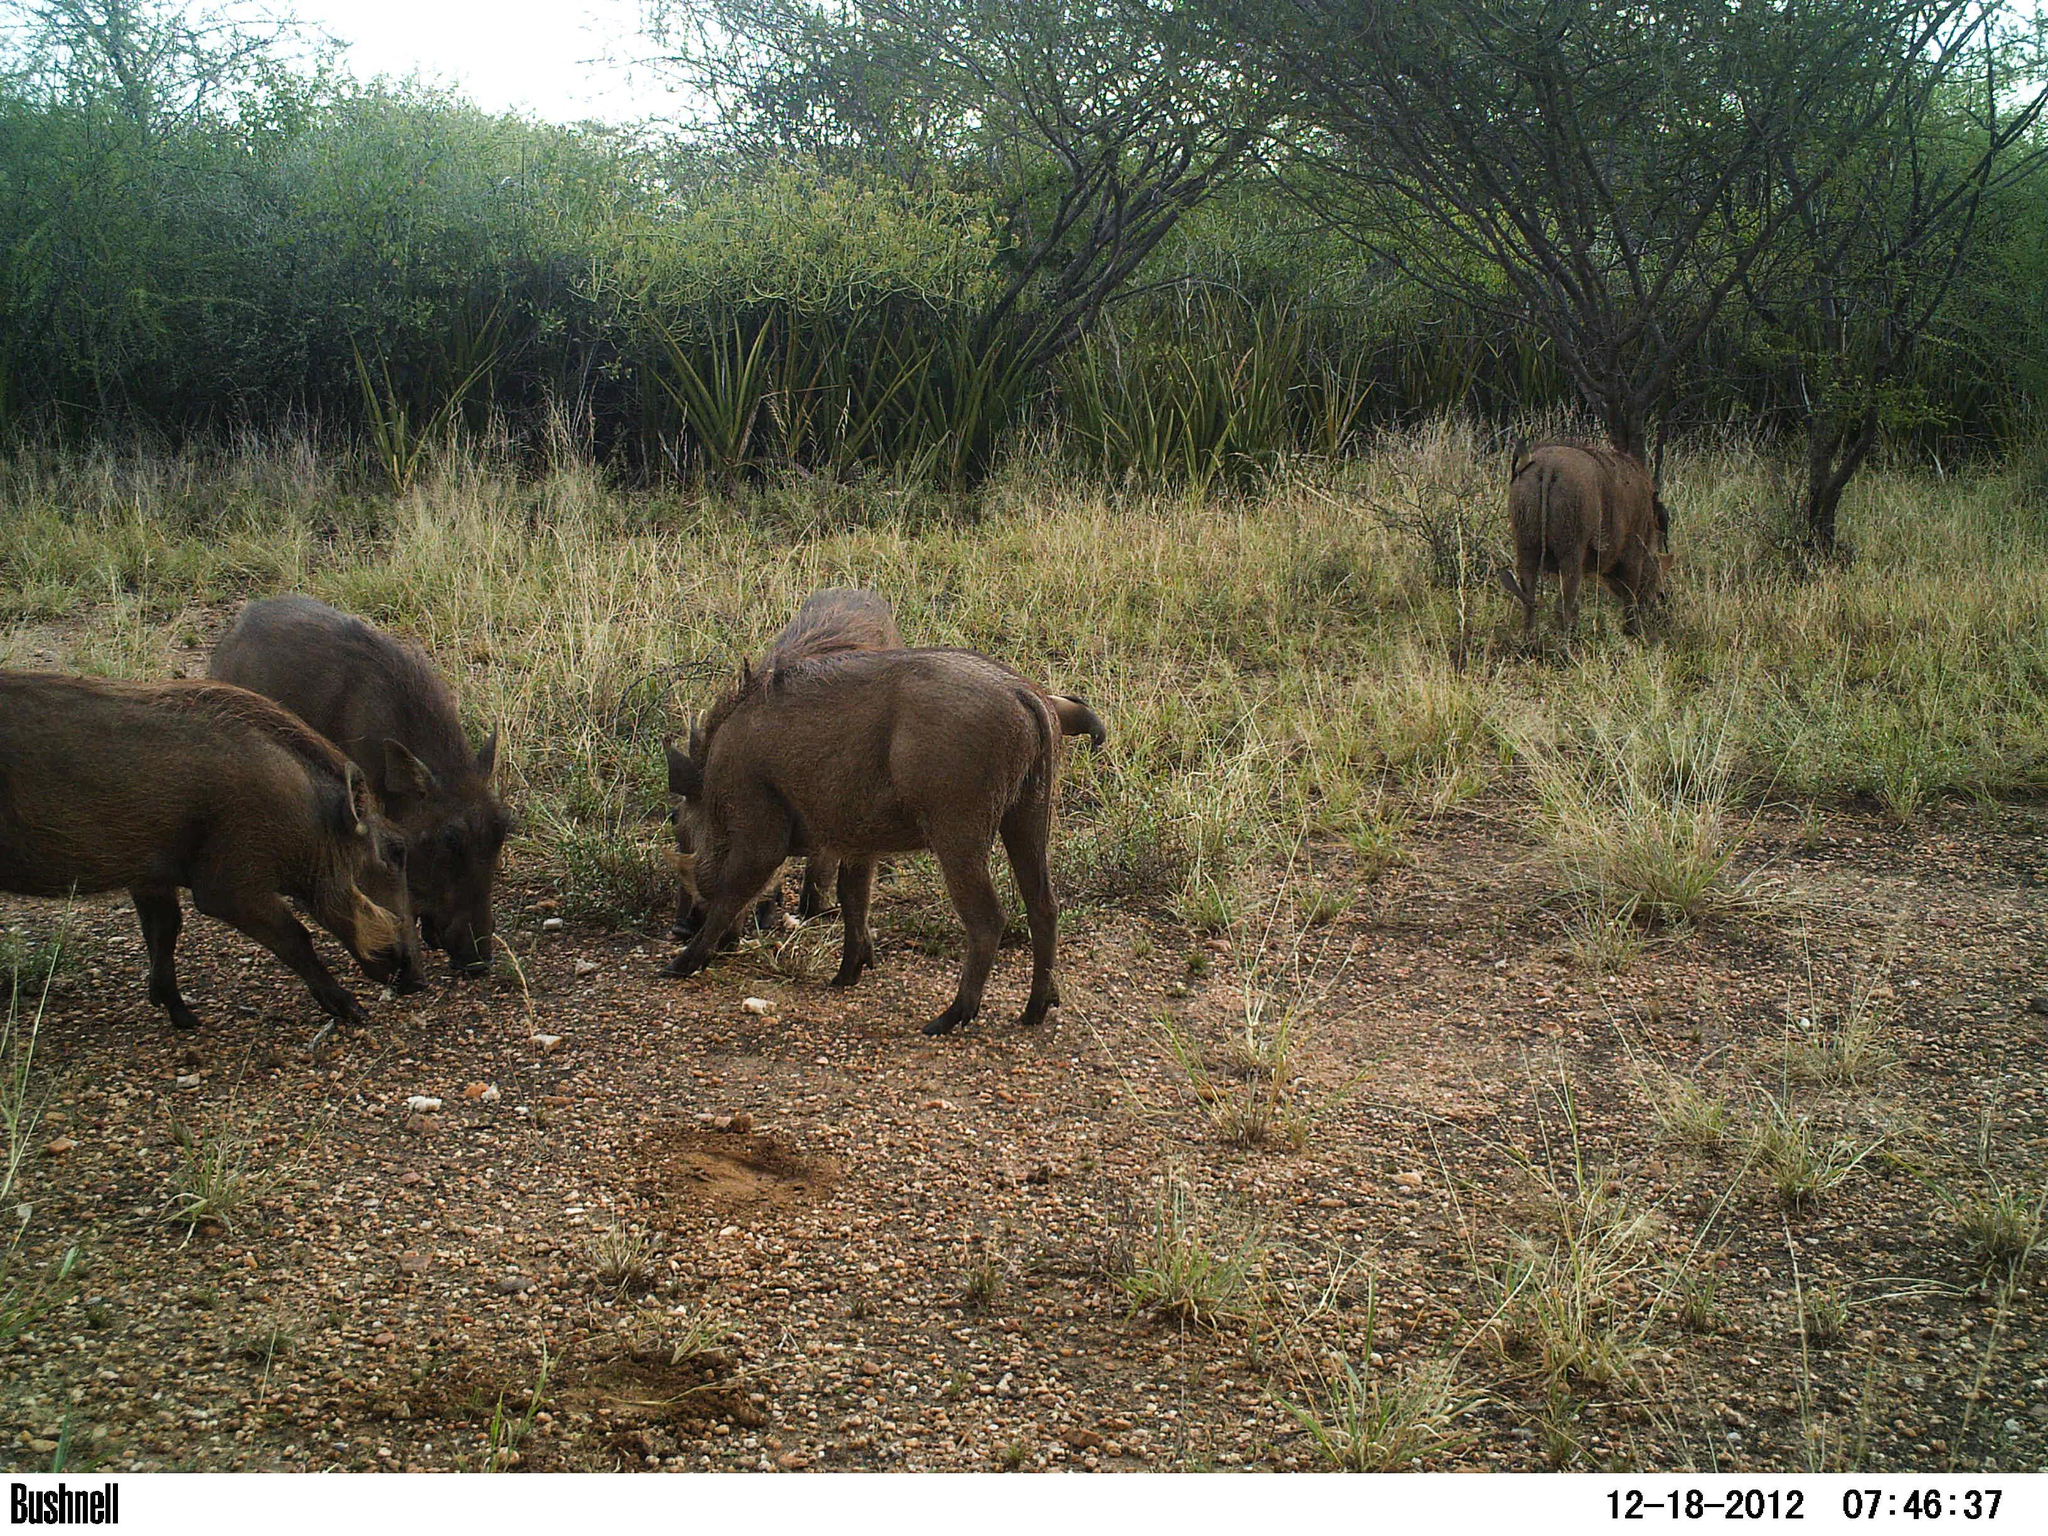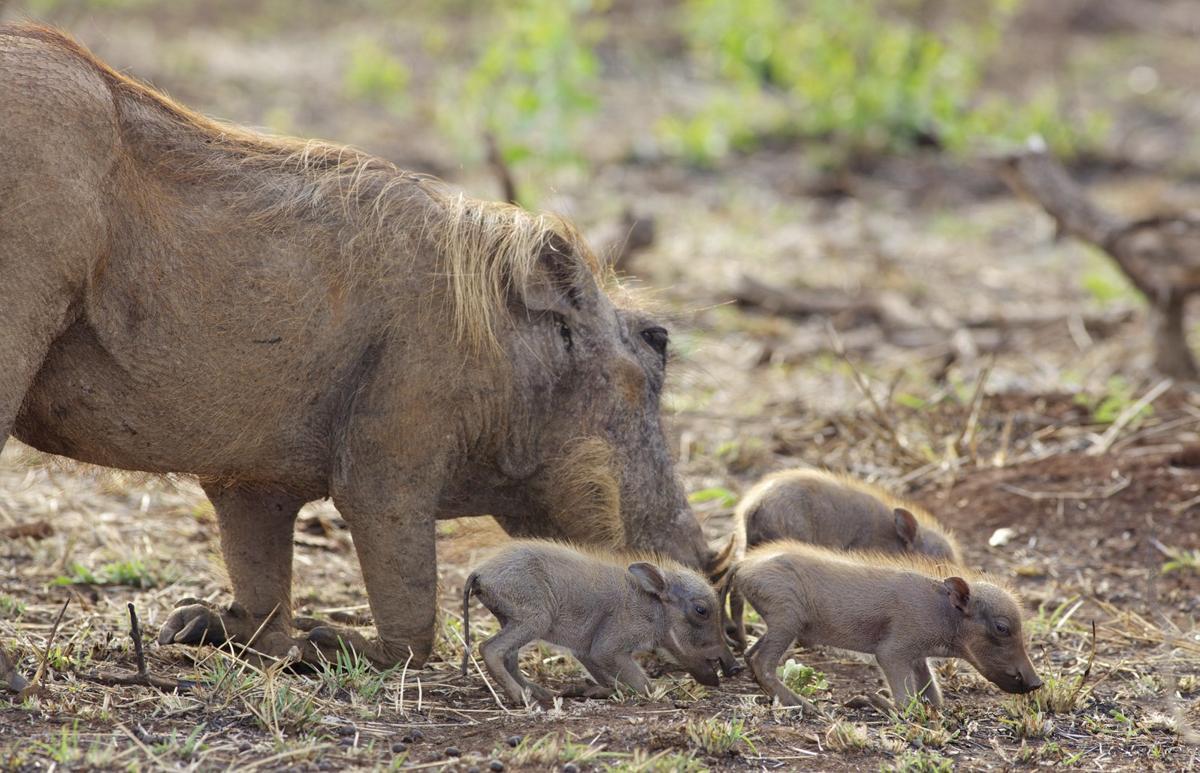The first image is the image on the left, the second image is the image on the right. Given the left and right images, does the statement "One of the images has only one wart hog with two tusks." hold true? Answer yes or no. No. The first image is the image on the left, the second image is the image on the right. For the images shown, is this caption "There at least one lone animal that has large tusks." true? Answer yes or no. No. 